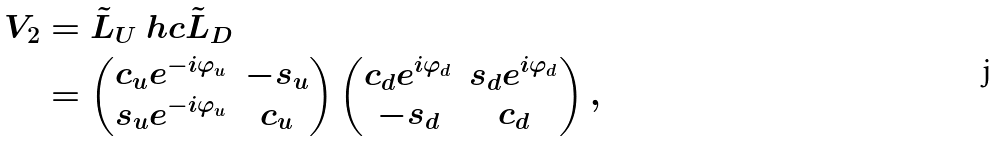<formula> <loc_0><loc_0><loc_500><loc_500>V _ { 2 } & = \tilde { L } _ { U } \ h c \tilde { L } _ { D } \\ & = \begin{pmatrix} c _ { u } e ^ { - i \varphi _ { u } } & - s _ { u } \\ s _ { u } e ^ { - i \varphi _ { u } } & c _ { u } \end{pmatrix} \begin{pmatrix} c _ { d } e ^ { i \varphi _ { d } } & s _ { d } e ^ { i \varphi _ { d } } \\ - s _ { d } & c _ { d } \end{pmatrix} ,</formula> 